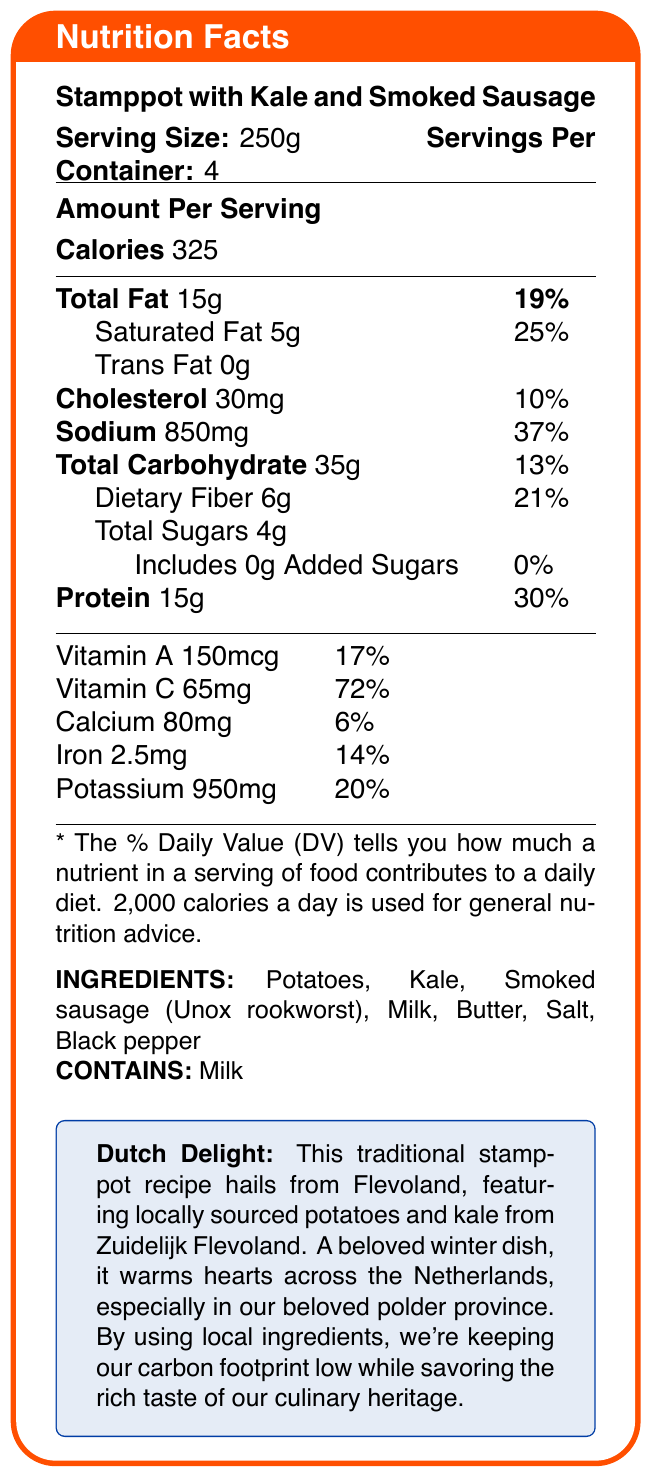what is the serving size? The serving size is stated as "Serving Size: 250g" at the top of the document under the title "Nutrition Facts."
Answer: 250g how many servings are in each container? The servings per container is mentioned as "Servings Per Container: 4" at the top of the document.
Answer: 4 how many calories are there per serving? The calorie amount is listed as "Calories 325" in the "Amount Per Serving" section of the document.
Answer: 325 what is the percentage daily value of sodium? The percentage daily value for sodium is listed as "Sodium 850mg 37%" in the table under the "Amount Per Serving" section.
Answer: 37% what is the total fat content per serving? The total fat content is listed as "Total Fat 15g 19%" in the table under the "Amount Per Serving" section.
Answer: 15g how much protein is in each serving? The amount of protein per serving is listed as "Protein 15g 30%" in the table under the "Amount Per Serving" section.
Answer: 15g which vitamin has the highest daily value percentage per serving? The daily value percentage for Vitamin C is listed as "Vitamin C 65mg 72%," which is higher compared to the percentages of other vitamins and minerals listed in the table.
Answer: Vitamin C at 72% which ingredients are used in the stamppot? A. Potatoes, Kale, and Smoked sausage (Unox rookworst) B. Butter, Salt, and Pepper C. All of the above The ingredients are listed as "Potatoes, Kale, Smoked sausage (Unox rookworst), Milk, Butter, Salt, Black pepper," meaning all options are correct.
Answer: C. All of the above what allergens are present in the dish? A. Gluten B. Milk C. Nuts The document specifically lists "CONTAINS: Milk," indicating milk is the allergen.
Answer: B. Milk does the dish include any added sugars? The document states "Includes 0g Added Sugars 0%" in the table under the "Amount Per Serving" section.
Answer: No is this dish a good source of dietary fiber? The dietary fiber content is 6g per serving, which is 21% of the daily value, indicating it is a good source of dietary fiber.
Answer: Yes summarize the main idea of the document. The document outlines the nutritional facts for stamppot with kale and smoked sausage, including serving size, calories, fat, cholesterol, sodium, carbohydrates, fiber, sugars, protein, vitamins, and minerals. Ingredients and allergens are listed, along with a note on the dish's traditional and sustainable aspects.
Answer: The document provides nutritional information about a traditional Dutch dish called stamppot with kale and smoked sausage, detailing serving size, calorie content, and other nutritional values. It also mentions ingredients, allergens, and additional notes on the recipe's cultural significance and sustainability. what is the origin of the traditional recipe? The additional information box states that the recipe is "a traditional Dutch recipe from Flevoland."
Answer: Flevoland, the Netherlands what is the purpose of using locally sourced ingredients? The additional information mentions that "By using local ingredients, we're keeping our carbon footprint low."
Answer: To reduce carbon footprint how much cholesterol is there per serving? The cholesterol content is listed as "Cholesterol 30mg 10%" in the table under the "Amount Per Serving" section.
Answer: 30mg what is the color of the box frame in the document? The document specifies "colframe=dutchorange" as the color for the box frame.
Answer: Dutch orange what percentage of daily value does the calcium content provide? The percentage daily value for calcium is listed as "Calcium 80mg 6%" in the table under the "Amount Per Serving" section.
Answer: 6% is the potassium content higher than the sodium content? The potassium content is listed as 950mg and the sodium content as 850mg, but the percentage daily value indicates the sodium content contributes more at 37%, while potassium contributes 20%.
Answer: No where are the potatoes and kale sourced from? The additional information box states that the potatoes and kale are "sourced from Zuidelijk Flevoland."
Answer: Zuidelijk Flevoland how much vitamin A is present in each serving? The amount of vitamin A per serving is listed as "Vitamin A 150mcg 17%" in the table under the "Amount Per Serving" section.
Answer: 150mcg what does the document say about the cultural significance of the dish? The additional information highlights that it is a "Popular winter dish in the Netherlands, especially in Flevoland."
Answer: Popular winter dish in the Netherlands, especially in Flevoland which company provides the smoked sausage used in the recipe? The ingredients list specifies "Smoked sausage (Unox rookworst)" as one of the components.
Answer: Unox 